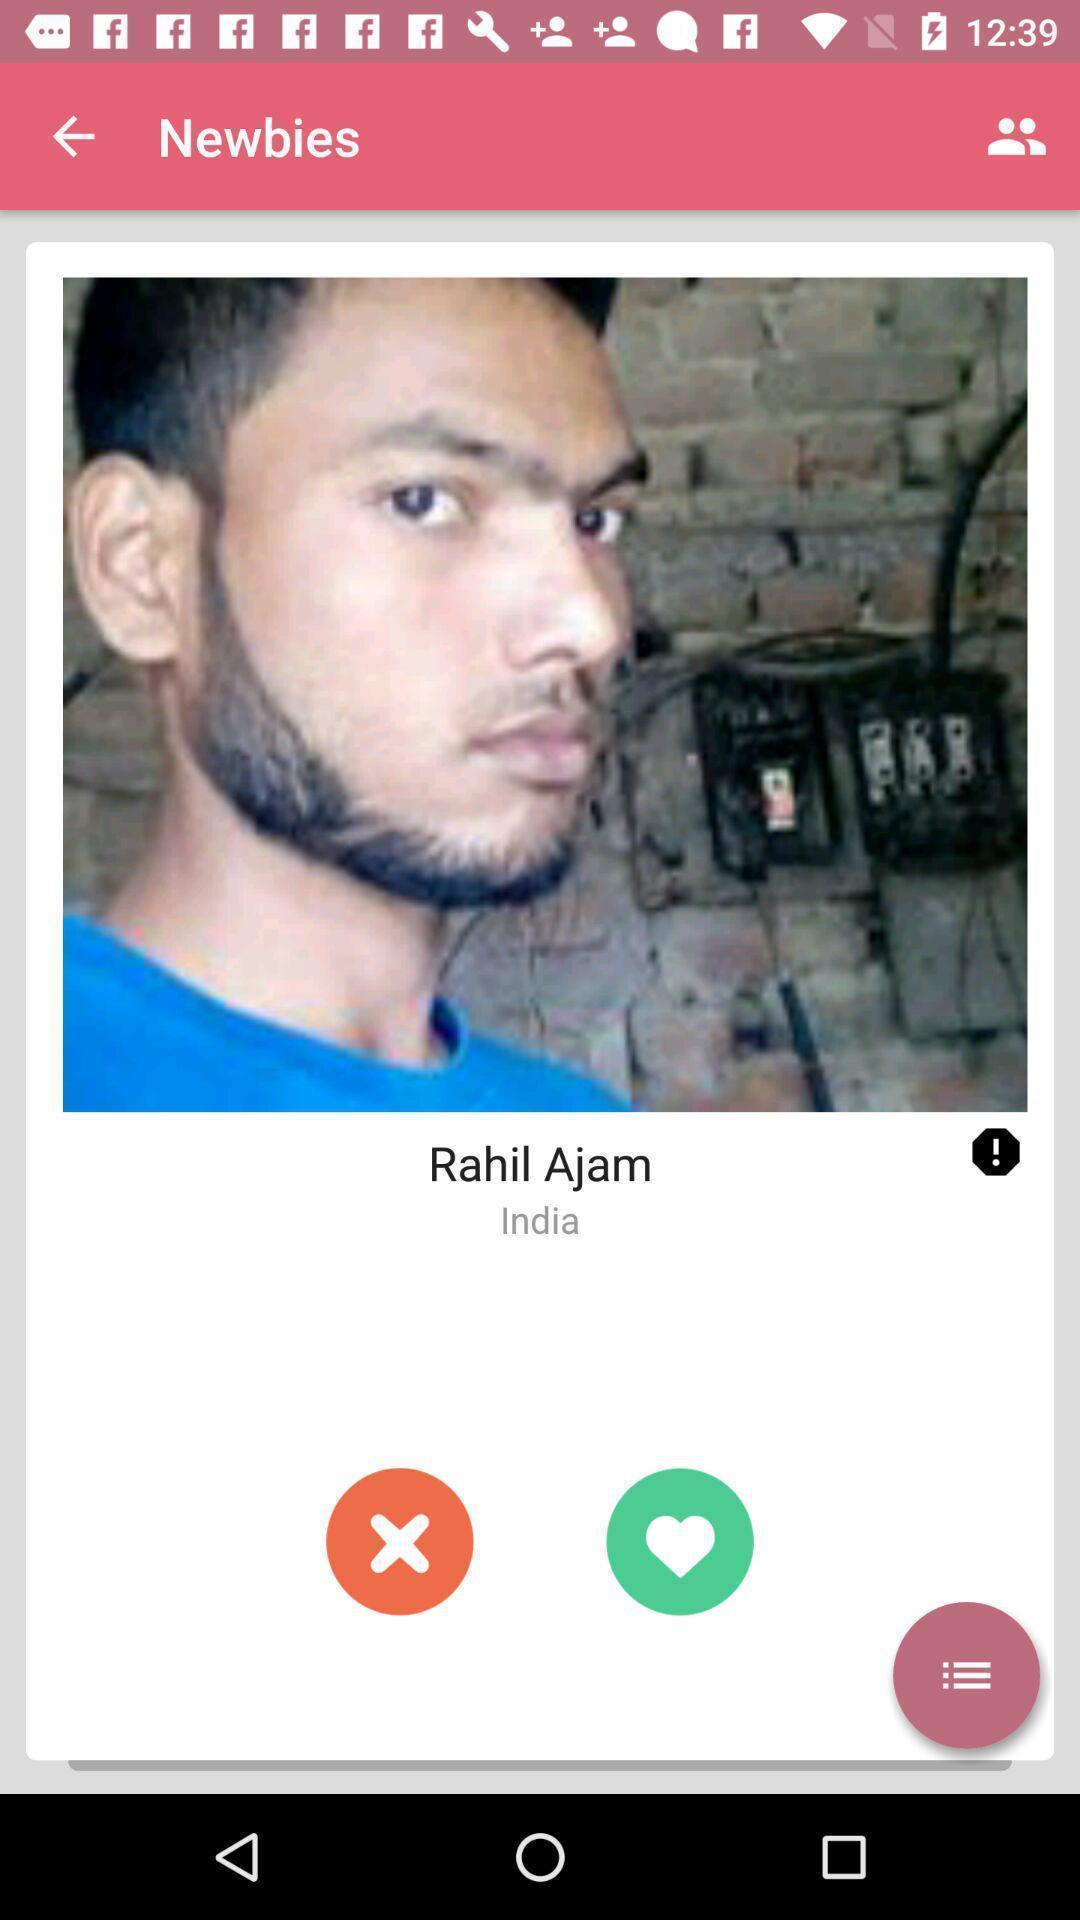Please provide a description for this image. Screen shows profile of a person. 